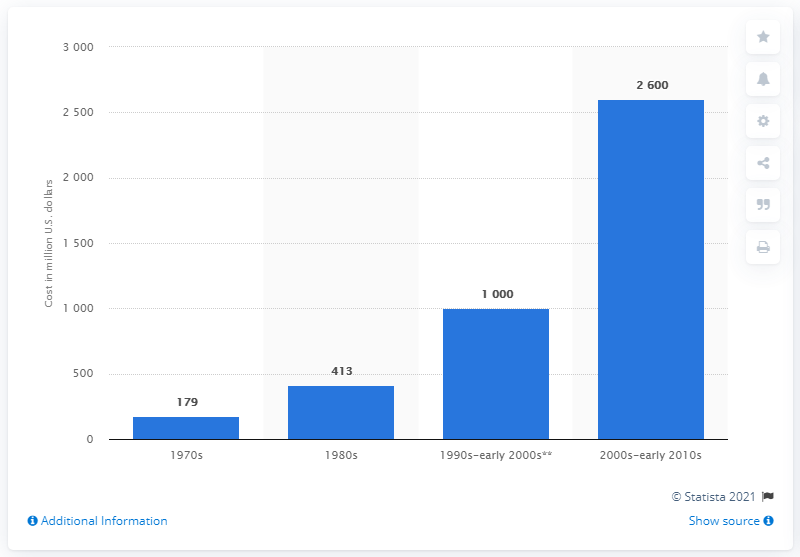Identify some key points in this picture. During the period of 1990 to 1999, the cost of drug development in the United States was approximately 2,600. The cost of drug development from 1990 to 1999 was approximately 2,600. 